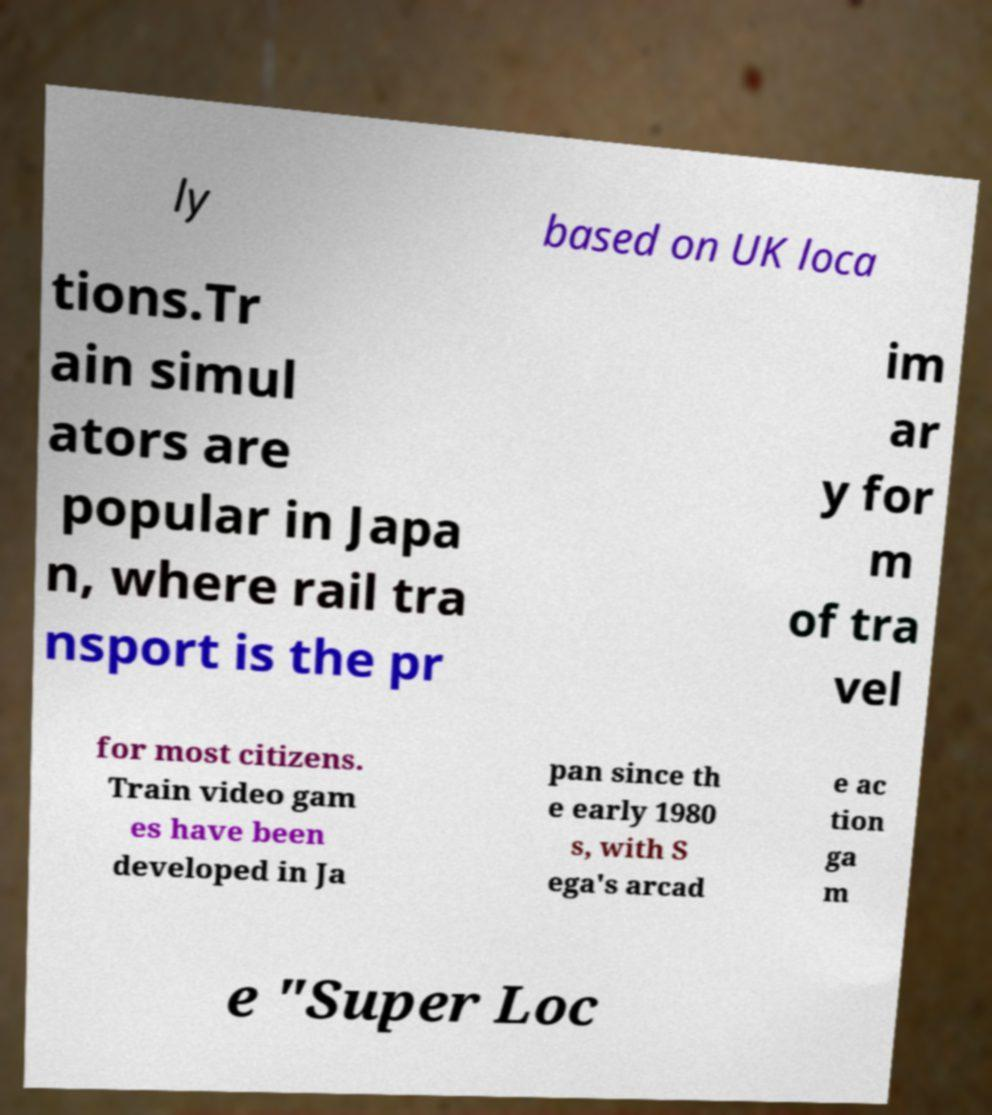Could you extract and type out the text from this image? ly based on UK loca tions.Tr ain simul ators are popular in Japa n, where rail tra nsport is the pr im ar y for m of tra vel for most citizens. Train video gam es have been developed in Ja pan since th e early 1980 s, with S ega's arcad e ac tion ga m e "Super Loc 